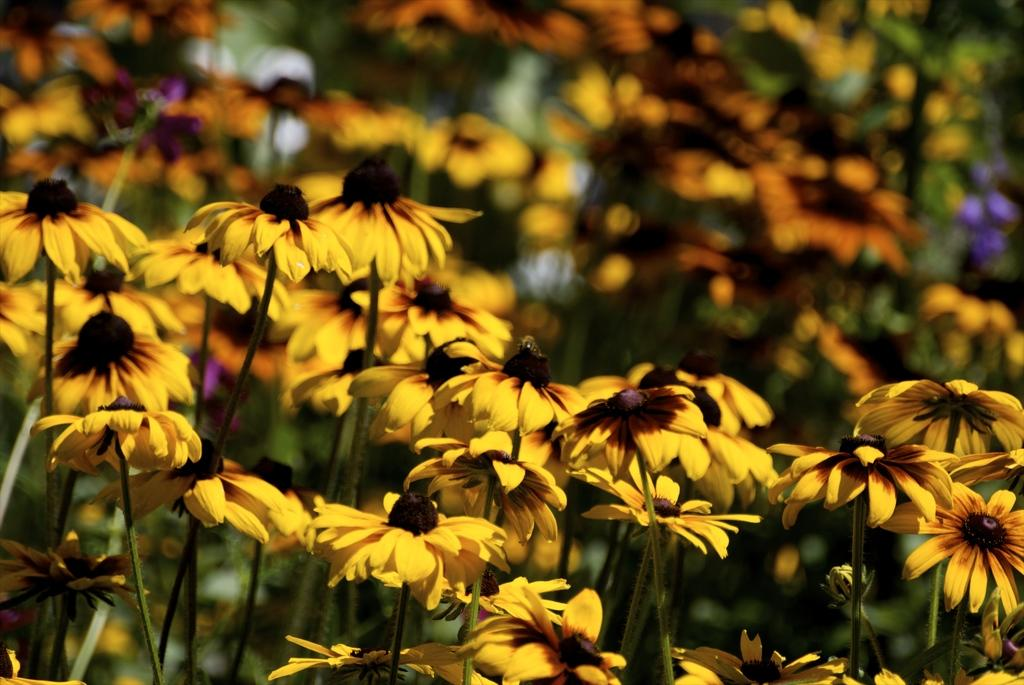What type of objects are present in the image? There are flowers in the image. Can you describe the color of the flowers? The flowers are yellow. How would you describe the background of the image? The background of the image is blurred. Where is the vase located in the image? There is no vase present in the image. Can you see the sea in the background of the image? The image does not depict a sea or any water body; it features flowers with a blurred background. 